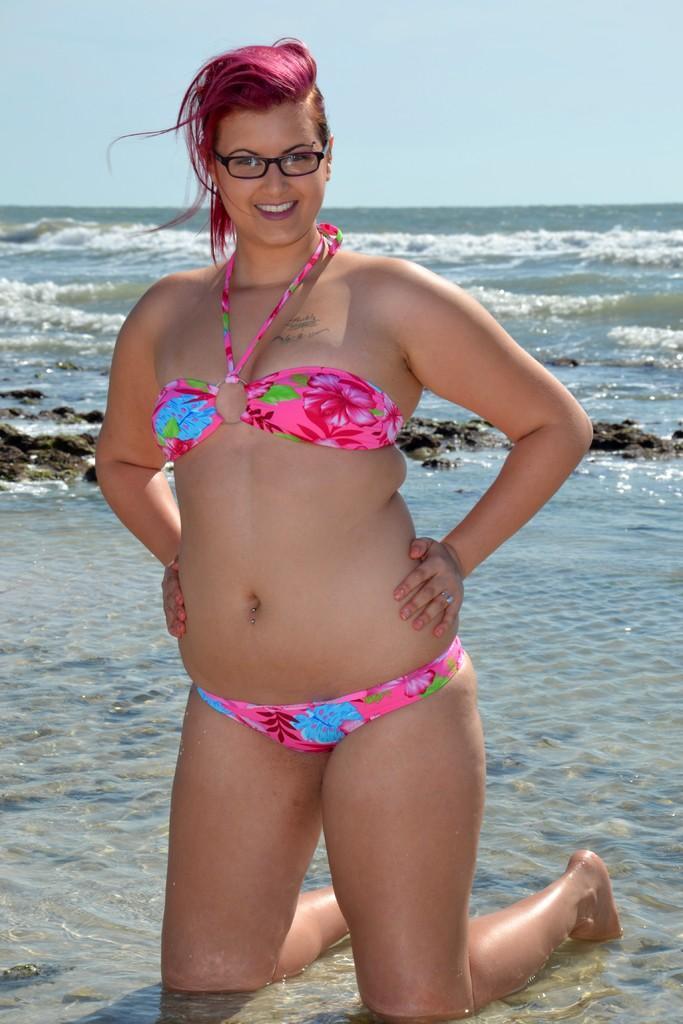In one or two sentences, can you explain what this image depicts? In this image I can see the person. I can see the water and the sky. 